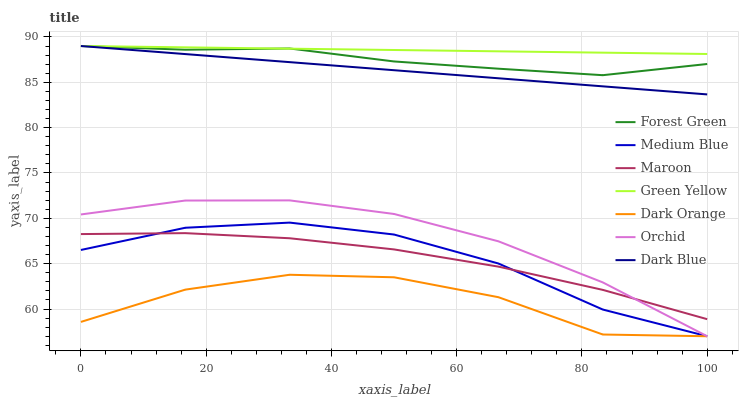Does Dark Orange have the minimum area under the curve?
Answer yes or no. Yes. Does Green Yellow have the maximum area under the curve?
Answer yes or no. Yes. Does Medium Blue have the minimum area under the curve?
Answer yes or no. No. Does Medium Blue have the maximum area under the curve?
Answer yes or no. No. Is Green Yellow the smoothest?
Answer yes or no. Yes. Is Dark Orange the roughest?
Answer yes or no. Yes. Is Medium Blue the smoothest?
Answer yes or no. No. Is Medium Blue the roughest?
Answer yes or no. No. Does Dark Orange have the lowest value?
Answer yes or no. Yes. Does Maroon have the lowest value?
Answer yes or no. No. Does Green Yellow have the highest value?
Answer yes or no. Yes. Does Medium Blue have the highest value?
Answer yes or no. No. Is Dark Orange less than Forest Green?
Answer yes or no. Yes. Is Dark Blue greater than Medium Blue?
Answer yes or no. Yes. Does Maroon intersect Orchid?
Answer yes or no. Yes. Is Maroon less than Orchid?
Answer yes or no. No. Is Maroon greater than Orchid?
Answer yes or no. No. Does Dark Orange intersect Forest Green?
Answer yes or no. No. 